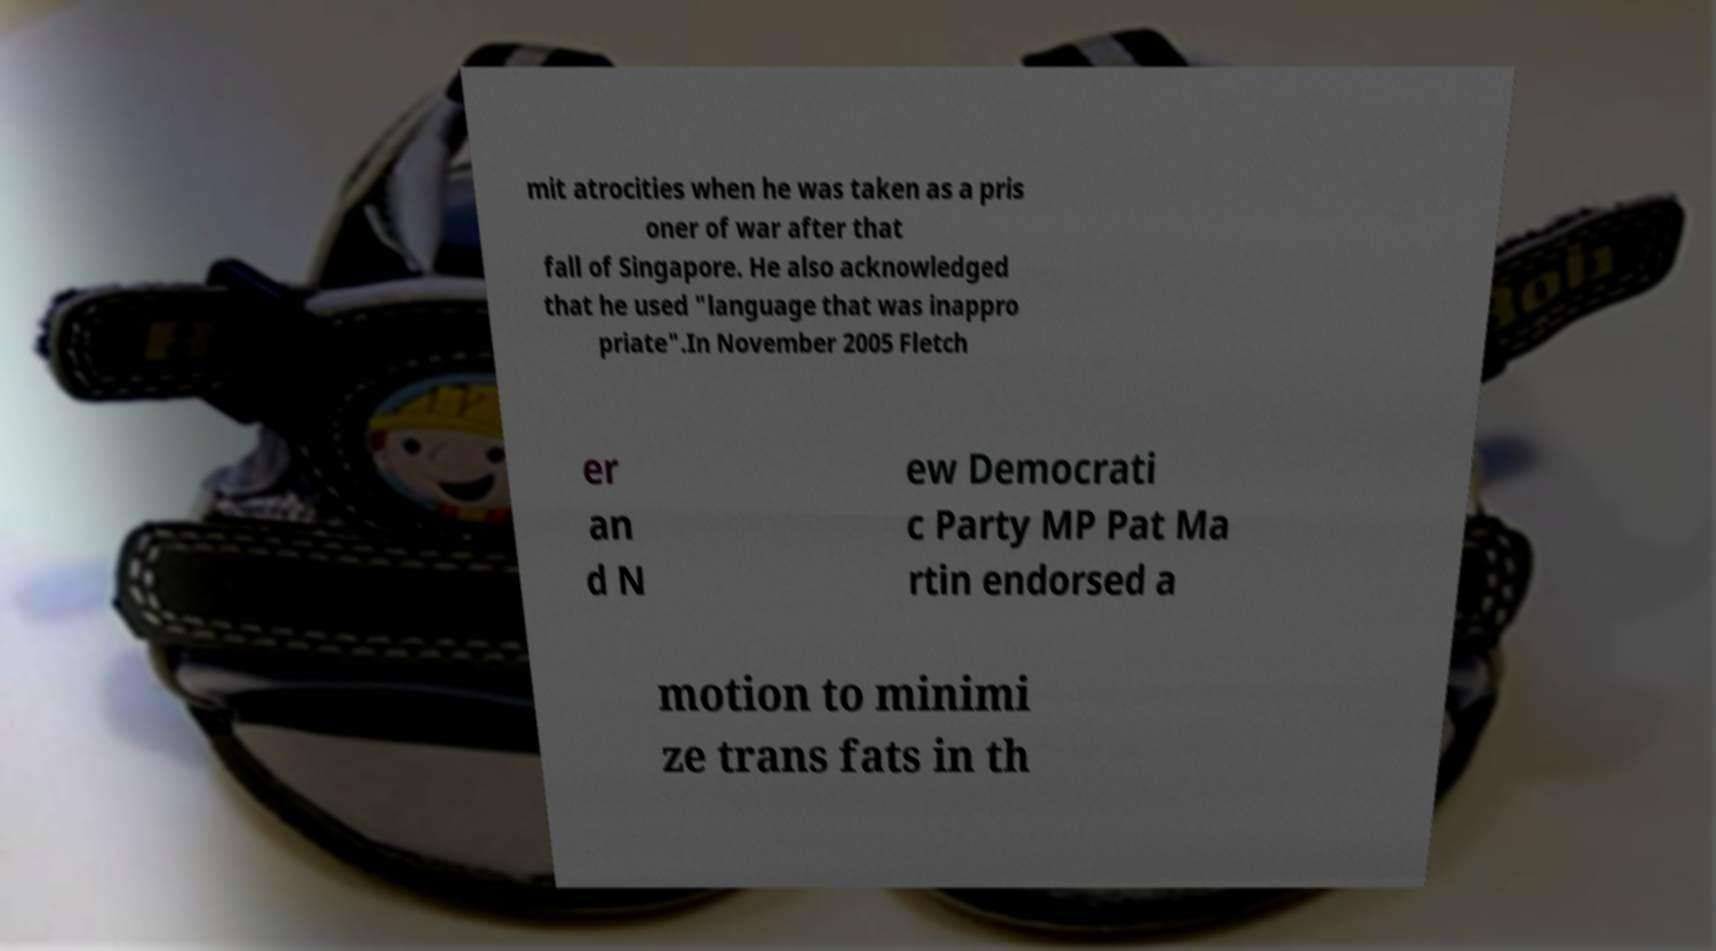For documentation purposes, I need the text within this image transcribed. Could you provide that? mit atrocities when he was taken as a pris oner of war after that fall of Singapore. He also acknowledged that he used "language that was inappro priate".In November 2005 Fletch er an d N ew Democrati c Party MP Pat Ma rtin endorsed a motion to minimi ze trans fats in th 